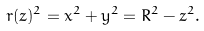<formula> <loc_0><loc_0><loc_500><loc_500>r ( z ) ^ { 2 } = x ^ { 2 } + y ^ { 2 } = R ^ { 2 } - z ^ { 2 } .</formula> 